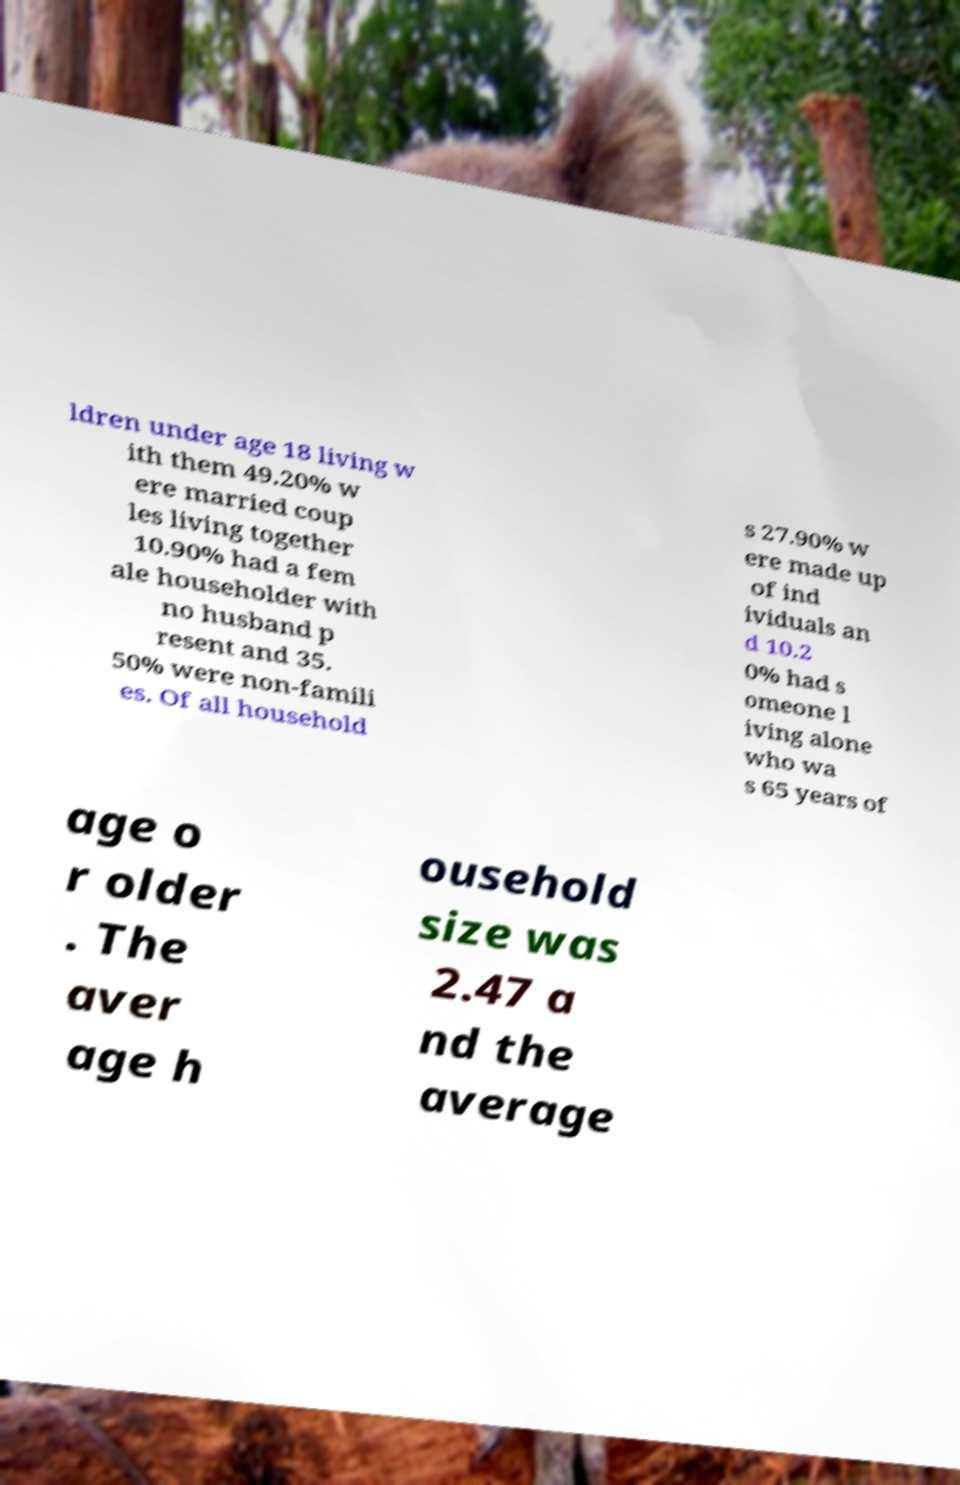There's text embedded in this image that I need extracted. Can you transcribe it verbatim? ldren under age 18 living w ith them 49.20% w ere married coup les living together 10.90% had a fem ale householder with no husband p resent and 35. 50% were non-famili es. Of all household s 27.90% w ere made up of ind ividuals an d 10.2 0% had s omeone l iving alone who wa s 65 years of age o r older . The aver age h ousehold size was 2.47 a nd the average 